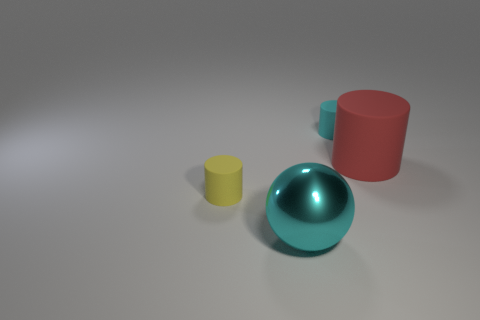Subtract all yellow cylinders. How many cylinders are left? 2 Add 4 cyan rubber cylinders. How many objects exist? 8 Subtract all balls. How many objects are left? 3 Subtract all red cylinders. How many cylinders are left? 2 Subtract 0 purple blocks. How many objects are left? 4 Subtract 1 spheres. How many spheres are left? 0 Subtract all brown cylinders. Subtract all purple cubes. How many cylinders are left? 3 Subtract all big red cylinders. Subtract all cyan rubber cylinders. How many objects are left? 2 Add 1 small yellow matte things. How many small yellow matte things are left? 2 Add 2 large red matte cylinders. How many large red matte cylinders exist? 3 